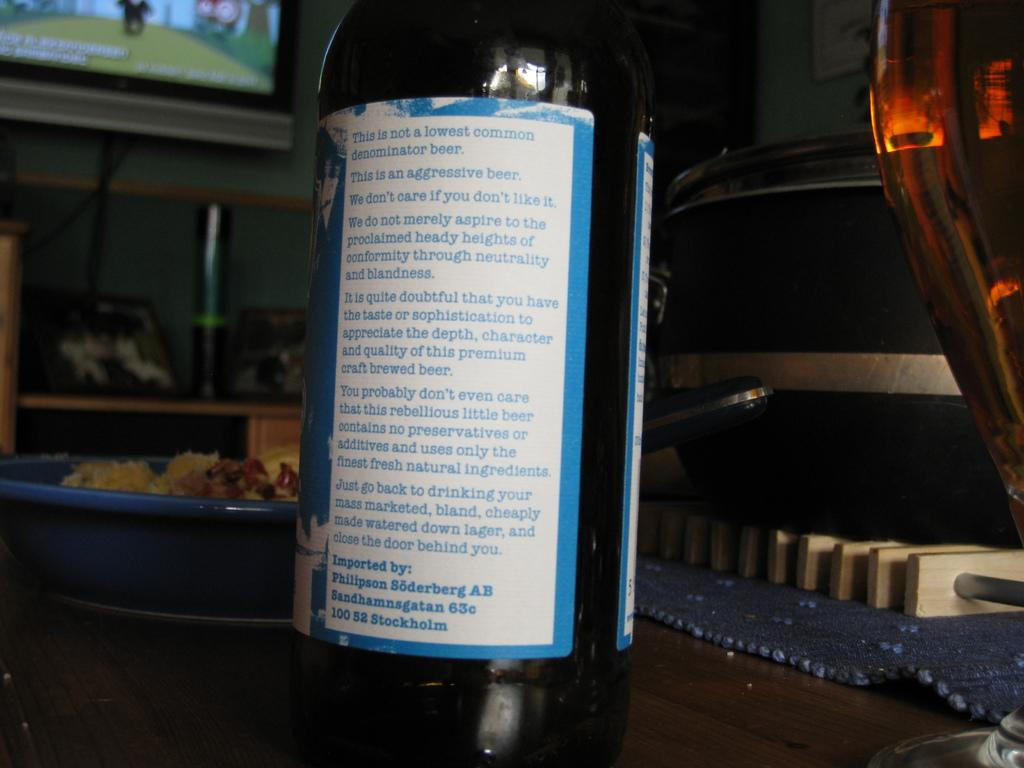<image>
Share a concise interpretation of the image provided. A bottle of wine that says This is not a lowest common denominator beer on its label. 